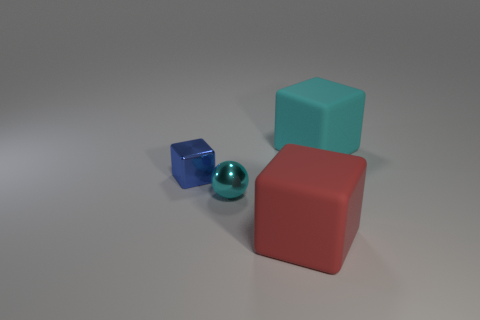Subtract all big blocks. How many blocks are left? 1 Add 2 big cyan rubber blocks. How many objects exist? 6 Subtract all red cubes. How many cubes are left? 2 Subtract all blocks. How many objects are left? 1 Subtract 0 brown balls. How many objects are left? 4 Subtract all green cubes. Subtract all blue cylinders. How many cubes are left? 3 Subtract all large cylinders. Subtract all spheres. How many objects are left? 3 Add 3 rubber objects. How many rubber objects are left? 5 Add 3 large cyan things. How many large cyan things exist? 4 